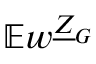Convert formula to latex. <formula><loc_0><loc_0><loc_500><loc_500>\mathbb { E } w ^ { \underline { Z } _ { G } }</formula> 